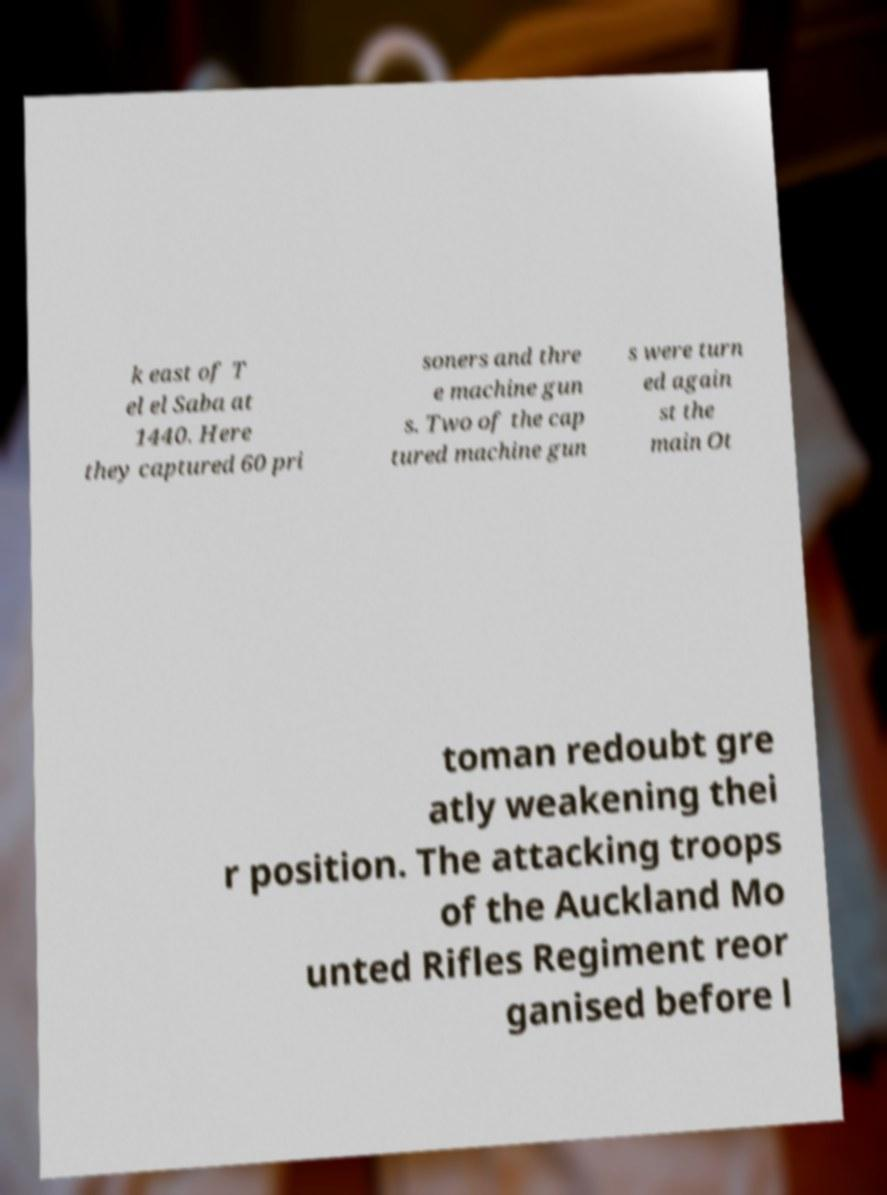Can you accurately transcribe the text from the provided image for me? k east of T el el Saba at 1440. Here they captured 60 pri soners and thre e machine gun s. Two of the cap tured machine gun s were turn ed again st the main Ot toman redoubt gre atly weakening thei r position. The attacking troops of the Auckland Mo unted Rifles Regiment reor ganised before l 